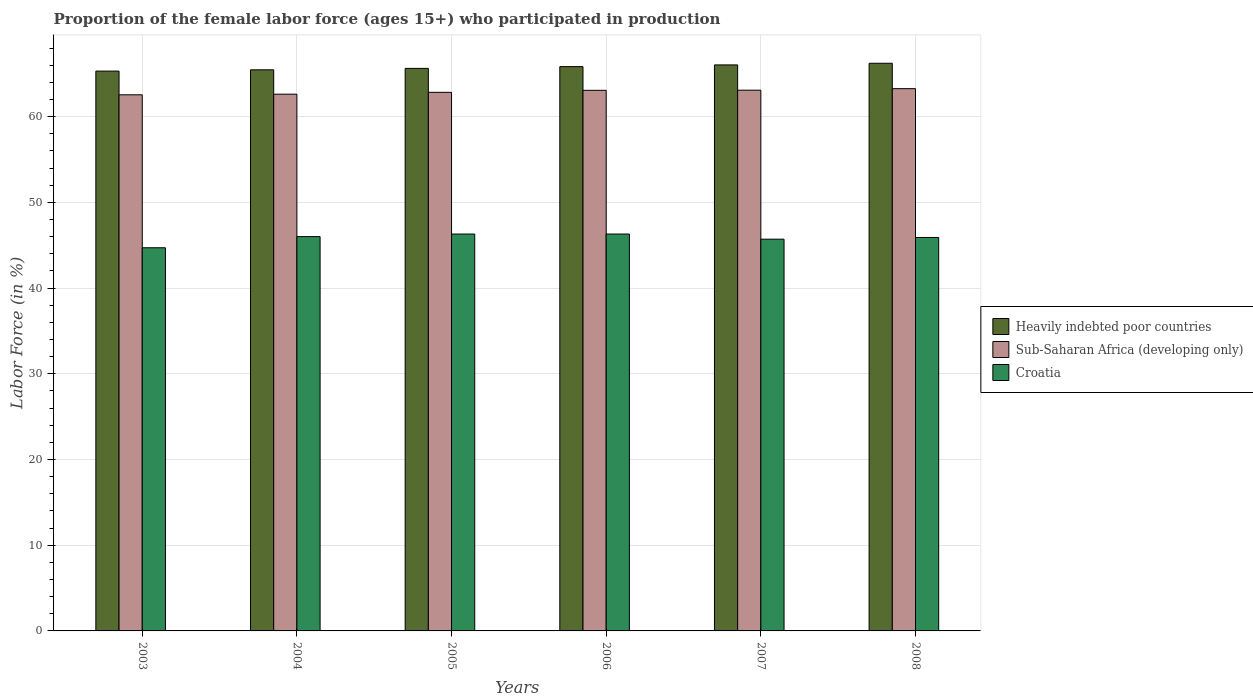How many different coloured bars are there?
Ensure brevity in your answer.  3. Are the number of bars per tick equal to the number of legend labels?
Provide a short and direct response. Yes. How many bars are there on the 4th tick from the right?
Keep it short and to the point. 3. What is the label of the 1st group of bars from the left?
Ensure brevity in your answer.  2003. What is the proportion of the female labor force who participated in production in Sub-Saharan Africa (developing only) in 2003?
Make the answer very short. 62.54. Across all years, what is the maximum proportion of the female labor force who participated in production in Sub-Saharan Africa (developing only)?
Offer a terse response. 63.26. Across all years, what is the minimum proportion of the female labor force who participated in production in Heavily indebted poor countries?
Your answer should be compact. 65.31. In which year was the proportion of the female labor force who participated in production in Heavily indebted poor countries minimum?
Offer a terse response. 2003. What is the total proportion of the female labor force who participated in production in Sub-Saharan Africa (developing only) in the graph?
Provide a succinct answer. 377.4. What is the difference between the proportion of the female labor force who participated in production in Croatia in 2006 and that in 2007?
Make the answer very short. 0.6. What is the difference between the proportion of the female labor force who participated in production in Heavily indebted poor countries in 2005 and the proportion of the female labor force who participated in production in Sub-Saharan Africa (developing only) in 2003?
Keep it short and to the point. 3.08. What is the average proportion of the female labor force who participated in production in Croatia per year?
Your response must be concise. 45.82. In the year 2004, what is the difference between the proportion of the female labor force who participated in production in Heavily indebted poor countries and proportion of the female labor force who participated in production in Sub-Saharan Africa (developing only)?
Your answer should be very brief. 2.84. What is the ratio of the proportion of the female labor force who participated in production in Heavily indebted poor countries in 2006 to that in 2008?
Provide a succinct answer. 0.99. Is the difference between the proportion of the female labor force who participated in production in Heavily indebted poor countries in 2003 and 2008 greater than the difference between the proportion of the female labor force who participated in production in Sub-Saharan Africa (developing only) in 2003 and 2008?
Offer a terse response. No. What is the difference between the highest and the second highest proportion of the female labor force who participated in production in Croatia?
Your answer should be compact. 0. What is the difference between the highest and the lowest proportion of the female labor force who participated in production in Heavily indebted poor countries?
Offer a terse response. 0.91. What does the 1st bar from the left in 2007 represents?
Give a very brief answer. Heavily indebted poor countries. What does the 1st bar from the right in 2008 represents?
Keep it short and to the point. Croatia. Is it the case that in every year, the sum of the proportion of the female labor force who participated in production in Sub-Saharan Africa (developing only) and proportion of the female labor force who participated in production in Croatia is greater than the proportion of the female labor force who participated in production in Heavily indebted poor countries?
Your response must be concise. Yes. How many bars are there?
Give a very brief answer. 18. Are all the bars in the graph horizontal?
Provide a short and direct response. No. How many years are there in the graph?
Offer a terse response. 6. Are the values on the major ticks of Y-axis written in scientific E-notation?
Your response must be concise. No. Does the graph contain any zero values?
Your response must be concise. No. How many legend labels are there?
Provide a succinct answer. 3. How are the legend labels stacked?
Your answer should be compact. Vertical. What is the title of the graph?
Offer a terse response. Proportion of the female labor force (ages 15+) who participated in production. Does "Cayman Islands" appear as one of the legend labels in the graph?
Your answer should be compact. No. What is the Labor Force (in %) of Heavily indebted poor countries in 2003?
Provide a succinct answer. 65.31. What is the Labor Force (in %) in Sub-Saharan Africa (developing only) in 2003?
Provide a short and direct response. 62.54. What is the Labor Force (in %) in Croatia in 2003?
Make the answer very short. 44.7. What is the Labor Force (in %) in Heavily indebted poor countries in 2004?
Provide a succinct answer. 65.46. What is the Labor Force (in %) of Sub-Saharan Africa (developing only) in 2004?
Provide a succinct answer. 62.62. What is the Labor Force (in %) in Heavily indebted poor countries in 2005?
Ensure brevity in your answer.  65.63. What is the Labor Force (in %) of Sub-Saharan Africa (developing only) in 2005?
Provide a succinct answer. 62.83. What is the Labor Force (in %) of Croatia in 2005?
Make the answer very short. 46.3. What is the Labor Force (in %) of Heavily indebted poor countries in 2006?
Make the answer very short. 65.83. What is the Labor Force (in %) in Sub-Saharan Africa (developing only) in 2006?
Make the answer very short. 63.07. What is the Labor Force (in %) in Croatia in 2006?
Offer a very short reply. 46.3. What is the Labor Force (in %) of Heavily indebted poor countries in 2007?
Your answer should be compact. 66.03. What is the Labor Force (in %) in Sub-Saharan Africa (developing only) in 2007?
Provide a short and direct response. 63.08. What is the Labor Force (in %) in Croatia in 2007?
Give a very brief answer. 45.7. What is the Labor Force (in %) of Heavily indebted poor countries in 2008?
Make the answer very short. 66.22. What is the Labor Force (in %) in Sub-Saharan Africa (developing only) in 2008?
Provide a succinct answer. 63.26. What is the Labor Force (in %) of Croatia in 2008?
Give a very brief answer. 45.9. Across all years, what is the maximum Labor Force (in %) of Heavily indebted poor countries?
Offer a terse response. 66.22. Across all years, what is the maximum Labor Force (in %) of Sub-Saharan Africa (developing only)?
Your answer should be compact. 63.26. Across all years, what is the maximum Labor Force (in %) in Croatia?
Provide a short and direct response. 46.3. Across all years, what is the minimum Labor Force (in %) of Heavily indebted poor countries?
Keep it short and to the point. 65.31. Across all years, what is the minimum Labor Force (in %) of Sub-Saharan Africa (developing only)?
Give a very brief answer. 62.54. Across all years, what is the minimum Labor Force (in %) in Croatia?
Provide a succinct answer. 44.7. What is the total Labor Force (in %) of Heavily indebted poor countries in the graph?
Your answer should be compact. 394.48. What is the total Labor Force (in %) of Sub-Saharan Africa (developing only) in the graph?
Provide a short and direct response. 377.4. What is the total Labor Force (in %) of Croatia in the graph?
Ensure brevity in your answer.  274.9. What is the difference between the Labor Force (in %) in Heavily indebted poor countries in 2003 and that in 2004?
Ensure brevity in your answer.  -0.15. What is the difference between the Labor Force (in %) in Sub-Saharan Africa (developing only) in 2003 and that in 2004?
Offer a very short reply. -0.07. What is the difference between the Labor Force (in %) of Heavily indebted poor countries in 2003 and that in 2005?
Give a very brief answer. -0.31. What is the difference between the Labor Force (in %) in Sub-Saharan Africa (developing only) in 2003 and that in 2005?
Make the answer very short. -0.29. What is the difference between the Labor Force (in %) of Croatia in 2003 and that in 2005?
Keep it short and to the point. -1.6. What is the difference between the Labor Force (in %) in Heavily indebted poor countries in 2003 and that in 2006?
Your answer should be very brief. -0.52. What is the difference between the Labor Force (in %) of Sub-Saharan Africa (developing only) in 2003 and that in 2006?
Your response must be concise. -0.52. What is the difference between the Labor Force (in %) of Croatia in 2003 and that in 2006?
Give a very brief answer. -1.6. What is the difference between the Labor Force (in %) of Heavily indebted poor countries in 2003 and that in 2007?
Your response must be concise. -0.72. What is the difference between the Labor Force (in %) of Sub-Saharan Africa (developing only) in 2003 and that in 2007?
Offer a terse response. -0.54. What is the difference between the Labor Force (in %) of Croatia in 2003 and that in 2007?
Your answer should be compact. -1. What is the difference between the Labor Force (in %) in Heavily indebted poor countries in 2003 and that in 2008?
Provide a short and direct response. -0.91. What is the difference between the Labor Force (in %) in Sub-Saharan Africa (developing only) in 2003 and that in 2008?
Keep it short and to the point. -0.72. What is the difference between the Labor Force (in %) in Croatia in 2003 and that in 2008?
Keep it short and to the point. -1.2. What is the difference between the Labor Force (in %) in Heavily indebted poor countries in 2004 and that in 2005?
Offer a very short reply. -0.17. What is the difference between the Labor Force (in %) in Sub-Saharan Africa (developing only) in 2004 and that in 2005?
Provide a short and direct response. -0.22. What is the difference between the Labor Force (in %) of Heavily indebted poor countries in 2004 and that in 2006?
Your answer should be very brief. -0.37. What is the difference between the Labor Force (in %) in Sub-Saharan Africa (developing only) in 2004 and that in 2006?
Offer a very short reply. -0.45. What is the difference between the Labor Force (in %) in Croatia in 2004 and that in 2006?
Offer a terse response. -0.3. What is the difference between the Labor Force (in %) in Heavily indebted poor countries in 2004 and that in 2007?
Your response must be concise. -0.57. What is the difference between the Labor Force (in %) of Sub-Saharan Africa (developing only) in 2004 and that in 2007?
Your answer should be compact. -0.47. What is the difference between the Labor Force (in %) in Croatia in 2004 and that in 2007?
Give a very brief answer. 0.3. What is the difference between the Labor Force (in %) in Heavily indebted poor countries in 2004 and that in 2008?
Provide a succinct answer. -0.77. What is the difference between the Labor Force (in %) of Sub-Saharan Africa (developing only) in 2004 and that in 2008?
Offer a very short reply. -0.64. What is the difference between the Labor Force (in %) in Heavily indebted poor countries in 2005 and that in 2006?
Ensure brevity in your answer.  -0.21. What is the difference between the Labor Force (in %) in Sub-Saharan Africa (developing only) in 2005 and that in 2006?
Keep it short and to the point. -0.23. What is the difference between the Labor Force (in %) in Croatia in 2005 and that in 2006?
Offer a terse response. 0. What is the difference between the Labor Force (in %) in Heavily indebted poor countries in 2005 and that in 2007?
Ensure brevity in your answer.  -0.41. What is the difference between the Labor Force (in %) of Sub-Saharan Africa (developing only) in 2005 and that in 2007?
Keep it short and to the point. -0.25. What is the difference between the Labor Force (in %) of Heavily indebted poor countries in 2005 and that in 2008?
Provide a succinct answer. -0.6. What is the difference between the Labor Force (in %) in Sub-Saharan Africa (developing only) in 2005 and that in 2008?
Your response must be concise. -0.43. What is the difference between the Labor Force (in %) of Croatia in 2005 and that in 2008?
Your answer should be compact. 0.4. What is the difference between the Labor Force (in %) of Heavily indebted poor countries in 2006 and that in 2007?
Keep it short and to the point. -0.2. What is the difference between the Labor Force (in %) in Sub-Saharan Africa (developing only) in 2006 and that in 2007?
Provide a succinct answer. -0.02. What is the difference between the Labor Force (in %) in Croatia in 2006 and that in 2007?
Provide a short and direct response. 0.6. What is the difference between the Labor Force (in %) in Heavily indebted poor countries in 2006 and that in 2008?
Make the answer very short. -0.39. What is the difference between the Labor Force (in %) of Sub-Saharan Africa (developing only) in 2006 and that in 2008?
Offer a terse response. -0.19. What is the difference between the Labor Force (in %) in Croatia in 2006 and that in 2008?
Provide a short and direct response. 0.4. What is the difference between the Labor Force (in %) of Heavily indebted poor countries in 2007 and that in 2008?
Offer a very short reply. -0.19. What is the difference between the Labor Force (in %) in Sub-Saharan Africa (developing only) in 2007 and that in 2008?
Give a very brief answer. -0.18. What is the difference between the Labor Force (in %) in Croatia in 2007 and that in 2008?
Give a very brief answer. -0.2. What is the difference between the Labor Force (in %) of Heavily indebted poor countries in 2003 and the Labor Force (in %) of Sub-Saharan Africa (developing only) in 2004?
Make the answer very short. 2.69. What is the difference between the Labor Force (in %) of Heavily indebted poor countries in 2003 and the Labor Force (in %) of Croatia in 2004?
Your response must be concise. 19.31. What is the difference between the Labor Force (in %) in Sub-Saharan Africa (developing only) in 2003 and the Labor Force (in %) in Croatia in 2004?
Your response must be concise. 16.54. What is the difference between the Labor Force (in %) in Heavily indebted poor countries in 2003 and the Labor Force (in %) in Sub-Saharan Africa (developing only) in 2005?
Ensure brevity in your answer.  2.48. What is the difference between the Labor Force (in %) in Heavily indebted poor countries in 2003 and the Labor Force (in %) in Croatia in 2005?
Make the answer very short. 19.01. What is the difference between the Labor Force (in %) of Sub-Saharan Africa (developing only) in 2003 and the Labor Force (in %) of Croatia in 2005?
Offer a terse response. 16.24. What is the difference between the Labor Force (in %) of Heavily indebted poor countries in 2003 and the Labor Force (in %) of Sub-Saharan Africa (developing only) in 2006?
Ensure brevity in your answer.  2.24. What is the difference between the Labor Force (in %) of Heavily indebted poor countries in 2003 and the Labor Force (in %) of Croatia in 2006?
Your response must be concise. 19.01. What is the difference between the Labor Force (in %) in Sub-Saharan Africa (developing only) in 2003 and the Labor Force (in %) in Croatia in 2006?
Offer a terse response. 16.24. What is the difference between the Labor Force (in %) in Heavily indebted poor countries in 2003 and the Labor Force (in %) in Sub-Saharan Africa (developing only) in 2007?
Give a very brief answer. 2.23. What is the difference between the Labor Force (in %) in Heavily indebted poor countries in 2003 and the Labor Force (in %) in Croatia in 2007?
Ensure brevity in your answer.  19.61. What is the difference between the Labor Force (in %) of Sub-Saharan Africa (developing only) in 2003 and the Labor Force (in %) of Croatia in 2007?
Keep it short and to the point. 16.84. What is the difference between the Labor Force (in %) in Heavily indebted poor countries in 2003 and the Labor Force (in %) in Sub-Saharan Africa (developing only) in 2008?
Make the answer very short. 2.05. What is the difference between the Labor Force (in %) in Heavily indebted poor countries in 2003 and the Labor Force (in %) in Croatia in 2008?
Your answer should be very brief. 19.41. What is the difference between the Labor Force (in %) of Sub-Saharan Africa (developing only) in 2003 and the Labor Force (in %) of Croatia in 2008?
Ensure brevity in your answer.  16.64. What is the difference between the Labor Force (in %) in Heavily indebted poor countries in 2004 and the Labor Force (in %) in Sub-Saharan Africa (developing only) in 2005?
Your answer should be compact. 2.63. What is the difference between the Labor Force (in %) in Heavily indebted poor countries in 2004 and the Labor Force (in %) in Croatia in 2005?
Ensure brevity in your answer.  19.16. What is the difference between the Labor Force (in %) in Sub-Saharan Africa (developing only) in 2004 and the Labor Force (in %) in Croatia in 2005?
Your response must be concise. 16.32. What is the difference between the Labor Force (in %) of Heavily indebted poor countries in 2004 and the Labor Force (in %) of Sub-Saharan Africa (developing only) in 2006?
Provide a succinct answer. 2.39. What is the difference between the Labor Force (in %) of Heavily indebted poor countries in 2004 and the Labor Force (in %) of Croatia in 2006?
Your answer should be very brief. 19.16. What is the difference between the Labor Force (in %) of Sub-Saharan Africa (developing only) in 2004 and the Labor Force (in %) of Croatia in 2006?
Offer a terse response. 16.32. What is the difference between the Labor Force (in %) of Heavily indebted poor countries in 2004 and the Labor Force (in %) of Sub-Saharan Africa (developing only) in 2007?
Make the answer very short. 2.37. What is the difference between the Labor Force (in %) in Heavily indebted poor countries in 2004 and the Labor Force (in %) in Croatia in 2007?
Provide a short and direct response. 19.76. What is the difference between the Labor Force (in %) in Sub-Saharan Africa (developing only) in 2004 and the Labor Force (in %) in Croatia in 2007?
Offer a very short reply. 16.92. What is the difference between the Labor Force (in %) in Heavily indebted poor countries in 2004 and the Labor Force (in %) in Sub-Saharan Africa (developing only) in 2008?
Keep it short and to the point. 2.2. What is the difference between the Labor Force (in %) of Heavily indebted poor countries in 2004 and the Labor Force (in %) of Croatia in 2008?
Keep it short and to the point. 19.56. What is the difference between the Labor Force (in %) of Sub-Saharan Africa (developing only) in 2004 and the Labor Force (in %) of Croatia in 2008?
Provide a succinct answer. 16.72. What is the difference between the Labor Force (in %) in Heavily indebted poor countries in 2005 and the Labor Force (in %) in Sub-Saharan Africa (developing only) in 2006?
Provide a short and direct response. 2.56. What is the difference between the Labor Force (in %) of Heavily indebted poor countries in 2005 and the Labor Force (in %) of Croatia in 2006?
Offer a very short reply. 19.33. What is the difference between the Labor Force (in %) in Sub-Saharan Africa (developing only) in 2005 and the Labor Force (in %) in Croatia in 2006?
Keep it short and to the point. 16.53. What is the difference between the Labor Force (in %) of Heavily indebted poor countries in 2005 and the Labor Force (in %) of Sub-Saharan Africa (developing only) in 2007?
Give a very brief answer. 2.54. What is the difference between the Labor Force (in %) in Heavily indebted poor countries in 2005 and the Labor Force (in %) in Croatia in 2007?
Provide a succinct answer. 19.93. What is the difference between the Labor Force (in %) of Sub-Saharan Africa (developing only) in 2005 and the Labor Force (in %) of Croatia in 2007?
Offer a terse response. 17.13. What is the difference between the Labor Force (in %) of Heavily indebted poor countries in 2005 and the Labor Force (in %) of Sub-Saharan Africa (developing only) in 2008?
Ensure brevity in your answer.  2.36. What is the difference between the Labor Force (in %) in Heavily indebted poor countries in 2005 and the Labor Force (in %) in Croatia in 2008?
Your response must be concise. 19.73. What is the difference between the Labor Force (in %) of Sub-Saharan Africa (developing only) in 2005 and the Labor Force (in %) of Croatia in 2008?
Offer a very short reply. 16.93. What is the difference between the Labor Force (in %) in Heavily indebted poor countries in 2006 and the Labor Force (in %) in Sub-Saharan Africa (developing only) in 2007?
Offer a very short reply. 2.75. What is the difference between the Labor Force (in %) in Heavily indebted poor countries in 2006 and the Labor Force (in %) in Croatia in 2007?
Your answer should be very brief. 20.13. What is the difference between the Labor Force (in %) of Sub-Saharan Africa (developing only) in 2006 and the Labor Force (in %) of Croatia in 2007?
Give a very brief answer. 17.37. What is the difference between the Labor Force (in %) in Heavily indebted poor countries in 2006 and the Labor Force (in %) in Sub-Saharan Africa (developing only) in 2008?
Your answer should be very brief. 2.57. What is the difference between the Labor Force (in %) of Heavily indebted poor countries in 2006 and the Labor Force (in %) of Croatia in 2008?
Make the answer very short. 19.93. What is the difference between the Labor Force (in %) in Sub-Saharan Africa (developing only) in 2006 and the Labor Force (in %) in Croatia in 2008?
Give a very brief answer. 17.17. What is the difference between the Labor Force (in %) of Heavily indebted poor countries in 2007 and the Labor Force (in %) of Sub-Saharan Africa (developing only) in 2008?
Keep it short and to the point. 2.77. What is the difference between the Labor Force (in %) of Heavily indebted poor countries in 2007 and the Labor Force (in %) of Croatia in 2008?
Offer a very short reply. 20.13. What is the difference between the Labor Force (in %) of Sub-Saharan Africa (developing only) in 2007 and the Labor Force (in %) of Croatia in 2008?
Offer a very short reply. 17.18. What is the average Labor Force (in %) in Heavily indebted poor countries per year?
Your answer should be very brief. 65.75. What is the average Labor Force (in %) in Sub-Saharan Africa (developing only) per year?
Ensure brevity in your answer.  62.9. What is the average Labor Force (in %) in Croatia per year?
Offer a very short reply. 45.82. In the year 2003, what is the difference between the Labor Force (in %) in Heavily indebted poor countries and Labor Force (in %) in Sub-Saharan Africa (developing only)?
Offer a terse response. 2.77. In the year 2003, what is the difference between the Labor Force (in %) in Heavily indebted poor countries and Labor Force (in %) in Croatia?
Provide a succinct answer. 20.61. In the year 2003, what is the difference between the Labor Force (in %) in Sub-Saharan Africa (developing only) and Labor Force (in %) in Croatia?
Provide a short and direct response. 17.84. In the year 2004, what is the difference between the Labor Force (in %) in Heavily indebted poor countries and Labor Force (in %) in Sub-Saharan Africa (developing only)?
Offer a very short reply. 2.84. In the year 2004, what is the difference between the Labor Force (in %) in Heavily indebted poor countries and Labor Force (in %) in Croatia?
Provide a succinct answer. 19.46. In the year 2004, what is the difference between the Labor Force (in %) in Sub-Saharan Africa (developing only) and Labor Force (in %) in Croatia?
Your answer should be very brief. 16.62. In the year 2005, what is the difference between the Labor Force (in %) in Heavily indebted poor countries and Labor Force (in %) in Sub-Saharan Africa (developing only)?
Offer a terse response. 2.79. In the year 2005, what is the difference between the Labor Force (in %) of Heavily indebted poor countries and Labor Force (in %) of Croatia?
Offer a terse response. 19.33. In the year 2005, what is the difference between the Labor Force (in %) in Sub-Saharan Africa (developing only) and Labor Force (in %) in Croatia?
Provide a succinct answer. 16.53. In the year 2006, what is the difference between the Labor Force (in %) in Heavily indebted poor countries and Labor Force (in %) in Sub-Saharan Africa (developing only)?
Make the answer very short. 2.77. In the year 2006, what is the difference between the Labor Force (in %) in Heavily indebted poor countries and Labor Force (in %) in Croatia?
Provide a succinct answer. 19.53. In the year 2006, what is the difference between the Labor Force (in %) of Sub-Saharan Africa (developing only) and Labor Force (in %) of Croatia?
Your answer should be compact. 16.77. In the year 2007, what is the difference between the Labor Force (in %) of Heavily indebted poor countries and Labor Force (in %) of Sub-Saharan Africa (developing only)?
Ensure brevity in your answer.  2.95. In the year 2007, what is the difference between the Labor Force (in %) in Heavily indebted poor countries and Labor Force (in %) in Croatia?
Make the answer very short. 20.33. In the year 2007, what is the difference between the Labor Force (in %) of Sub-Saharan Africa (developing only) and Labor Force (in %) of Croatia?
Your answer should be very brief. 17.38. In the year 2008, what is the difference between the Labor Force (in %) of Heavily indebted poor countries and Labor Force (in %) of Sub-Saharan Africa (developing only)?
Keep it short and to the point. 2.96. In the year 2008, what is the difference between the Labor Force (in %) in Heavily indebted poor countries and Labor Force (in %) in Croatia?
Provide a short and direct response. 20.32. In the year 2008, what is the difference between the Labor Force (in %) in Sub-Saharan Africa (developing only) and Labor Force (in %) in Croatia?
Provide a short and direct response. 17.36. What is the ratio of the Labor Force (in %) in Croatia in 2003 to that in 2004?
Provide a short and direct response. 0.97. What is the ratio of the Labor Force (in %) of Heavily indebted poor countries in 2003 to that in 2005?
Make the answer very short. 1. What is the ratio of the Labor Force (in %) of Croatia in 2003 to that in 2005?
Make the answer very short. 0.97. What is the ratio of the Labor Force (in %) in Heavily indebted poor countries in 2003 to that in 2006?
Provide a succinct answer. 0.99. What is the ratio of the Labor Force (in %) in Croatia in 2003 to that in 2006?
Offer a terse response. 0.97. What is the ratio of the Labor Force (in %) of Sub-Saharan Africa (developing only) in 2003 to that in 2007?
Offer a very short reply. 0.99. What is the ratio of the Labor Force (in %) in Croatia in 2003 to that in 2007?
Ensure brevity in your answer.  0.98. What is the ratio of the Labor Force (in %) of Heavily indebted poor countries in 2003 to that in 2008?
Your answer should be very brief. 0.99. What is the ratio of the Labor Force (in %) in Sub-Saharan Africa (developing only) in 2003 to that in 2008?
Make the answer very short. 0.99. What is the ratio of the Labor Force (in %) of Croatia in 2003 to that in 2008?
Keep it short and to the point. 0.97. What is the ratio of the Labor Force (in %) of Heavily indebted poor countries in 2004 to that in 2005?
Provide a succinct answer. 1. What is the ratio of the Labor Force (in %) in Croatia in 2004 to that in 2005?
Give a very brief answer. 0.99. What is the ratio of the Labor Force (in %) of Heavily indebted poor countries in 2004 to that in 2006?
Keep it short and to the point. 0.99. What is the ratio of the Labor Force (in %) in Sub-Saharan Africa (developing only) in 2004 to that in 2007?
Keep it short and to the point. 0.99. What is the ratio of the Labor Force (in %) in Croatia in 2004 to that in 2007?
Ensure brevity in your answer.  1.01. What is the ratio of the Labor Force (in %) of Heavily indebted poor countries in 2004 to that in 2008?
Offer a terse response. 0.99. What is the ratio of the Labor Force (in %) of Sub-Saharan Africa (developing only) in 2004 to that in 2008?
Make the answer very short. 0.99. What is the ratio of the Labor Force (in %) of Croatia in 2004 to that in 2008?
Provide a short and direct response. 1. What is the ratio of the Labor Force (in %) in Heavily indebted poor countries in 2005 to that in 2006?
Offer a very short reply. 1. What is the ratio of the Labor Force (in %) of Sub-Saharan Africa (developing only) in 2005 to that in 2007?
Make the answer very short. 1. What is the ratio of the Labor Force (in %) in Croatia in 2005 to that in 2007?
Provide a short and direct response. 1.01. What is the ratio of the Labor Force (in %) in Croatia in 2005 to that in 2008?
Give a very brief answer. 1.01. What is the ratio of the Labor Force (in %) in Croatia in 2006 to that in 2007?
Offer a terse response. 1.01. What is the ratio of the Labor Force (in %) of Heavily indebted poor countries in 2006 to that in 2008?
Your response must be concise. 0.99. What is the ratio of the Labor Force (in %) of Sub-Saharan Africa (developing only) in 2006 to that in 2008?
Provide a short and direct response. 1. What is the ratio of the Labor Force (in %) of Croatia in 2006 to that in 2008?
Give a very brief answer. 1.01. What is the ratio of the Labor Force (in %) in Heavily indebted poor countries in 2007 to that in 2008?
Your response must be concise. 1. What is the ratio of the Labor Force (in %) of Sub-Saharan Africa (developing only) in 2007 to that in 2008?
Your answer should be very brief. 1. What is the ratio of the Labor Force (in %) of Croatia in 2007 to that in 2008?
Ensure brevity in your answer.  1. What is the difference between the highest and the second highest Labor Force (in %) in Heavily indebted poor countries?
Ensure brevity in your answer.  0.19. What is the difference between the highest and the second highest Labor Force (in %) of Sub-Saharan Africa (developing only)?
Offer a terse response. 0.18. What is the difference between the highest and the second highest Labor Force (in %) of Croatia?
Provide a succinct answer. 0. What is the difference between the highest and the lowest Labor Force (in %) in Heavily indebted poor countries?
Your response must be concise. 0.91. What is the difference between the highest and the lowest Labor Force (in %) of Sub-Saharan Africa (developing only)?
Provide a succinct answer. 0.72. 